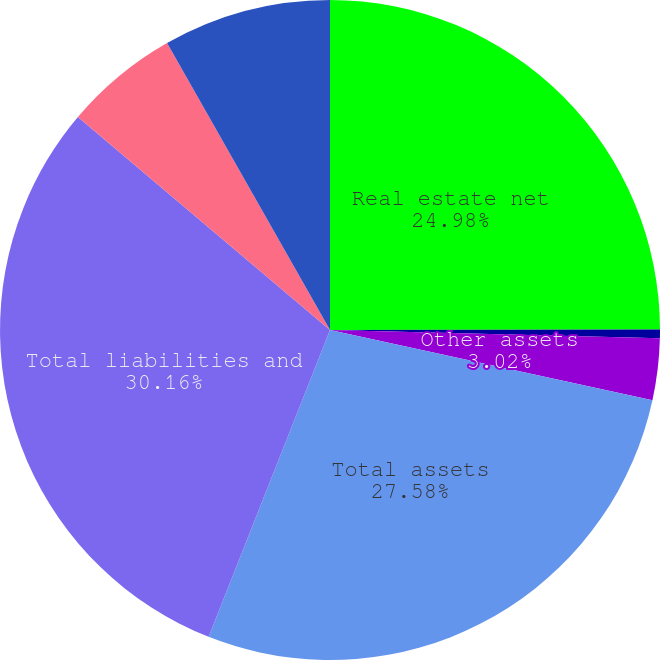Convert chart to OTSL. <chart><loc_0><loc_0><loc_500><loc_500><pie_chart><fcel>Real estate net<fcel>Cash<fcel>Other assets<fcel>Total assets<fcel>Total liabilities and<fcel>Our share of unconsolidated<fcel>Our investment in real estate<nl><fcel>24.98%<fcel>0.42%<fcel>3.02%<fcel>27.58%<fcel>30.17%<fcel>5.62%<fcel>8.22%<nl></chart> 